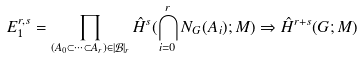Convert formula to latex. <formula><loc_0><loc_0><loc_500><loc_500>E _ { 1 } ^ { r , s } = \prod _ { ( A _ { 0 } \subset \cdots \subset A _ { r } ) \in | \mathcal { B } | _ { r } } \hat { H } ^ { s } ( \bigcap _ { i = 0 } ^ { r } N _ { G } ( A _ { i } ) ; M ) \Rightarrow \hat { H } ^ { r + s } ( G ; M )</formula> 